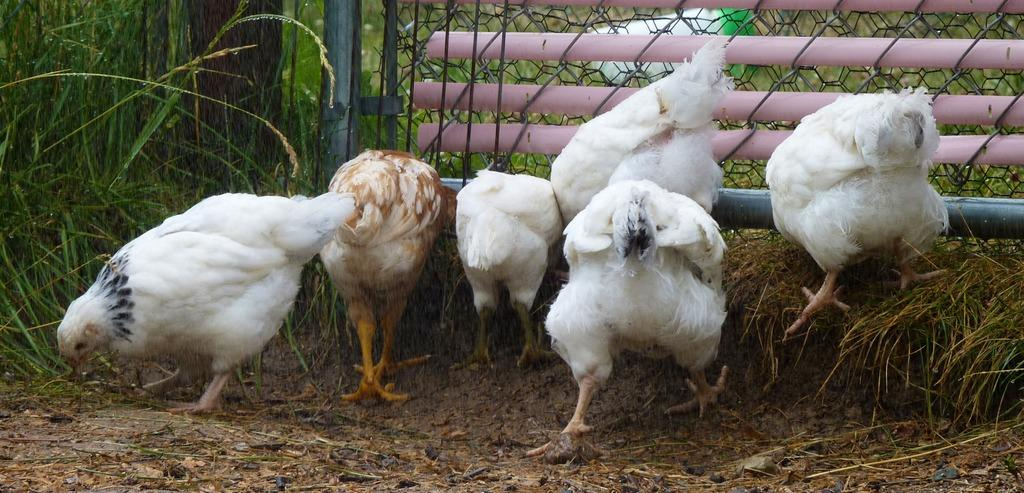What type of animals are in the image? There are hens in the image. What type of vegetation is visible in the image? There is grass visible in the image. What can be seen in the background of the image? There is a mesh fencing with poles in the background of the image. What type of moon can be seen in the image? There is no moon present in the image. What type of kettle is visible in the image? There is no kettle present in the image. 